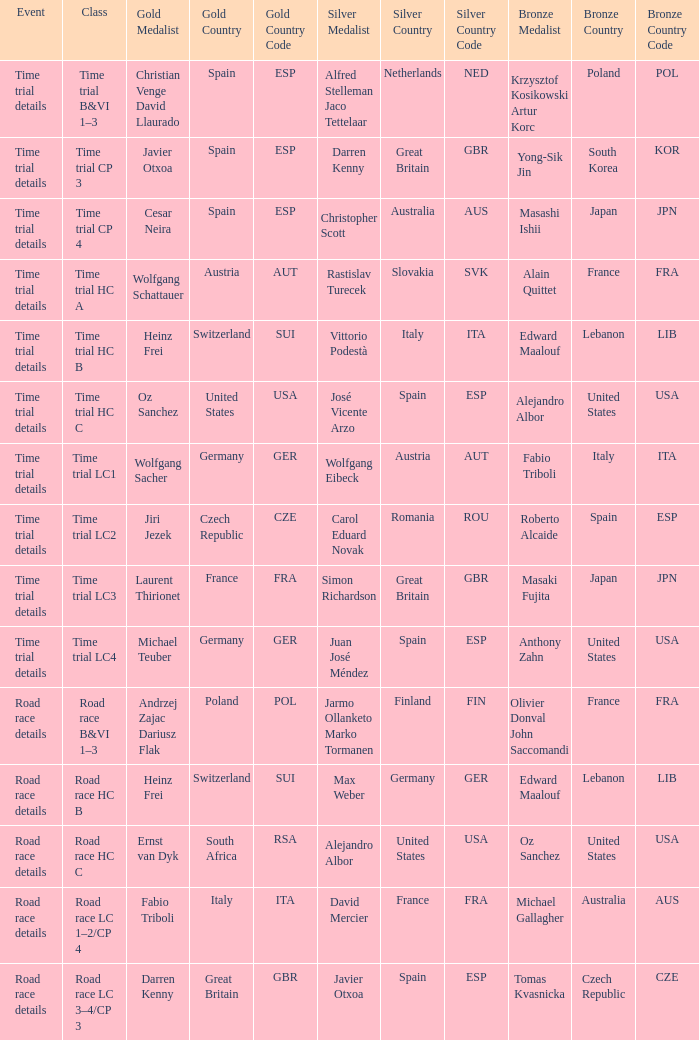What is the event when the class is time trial hc a? Time trial details. 